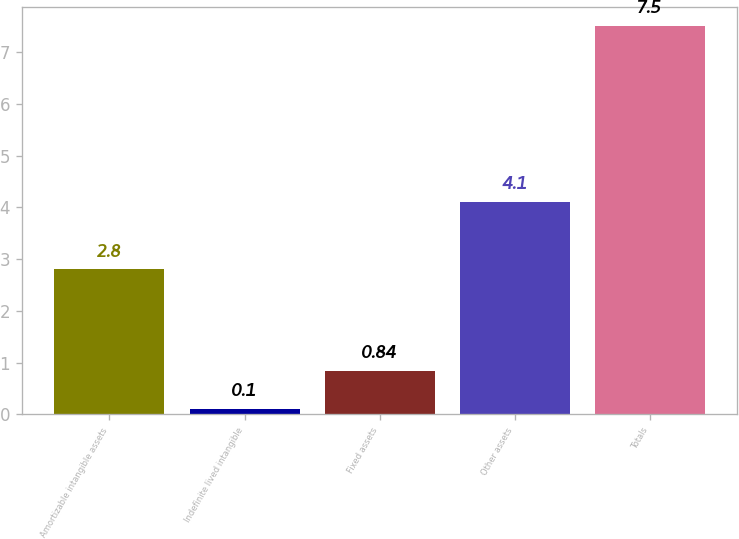Convert chart to OTSL. <chart><loc_0><loc_0><loc_500><loc_500><bar_chart><fcel>Amortizable intangible assets<fcel>Indefinite lived intangible<fcel>Fixed assets<fcel>Other assets<fcel>Totals<nl><fcel>2.8<fcel>0.1<fcel>0.84<fcel>4.1<fcel>7.5<nl></chart> 